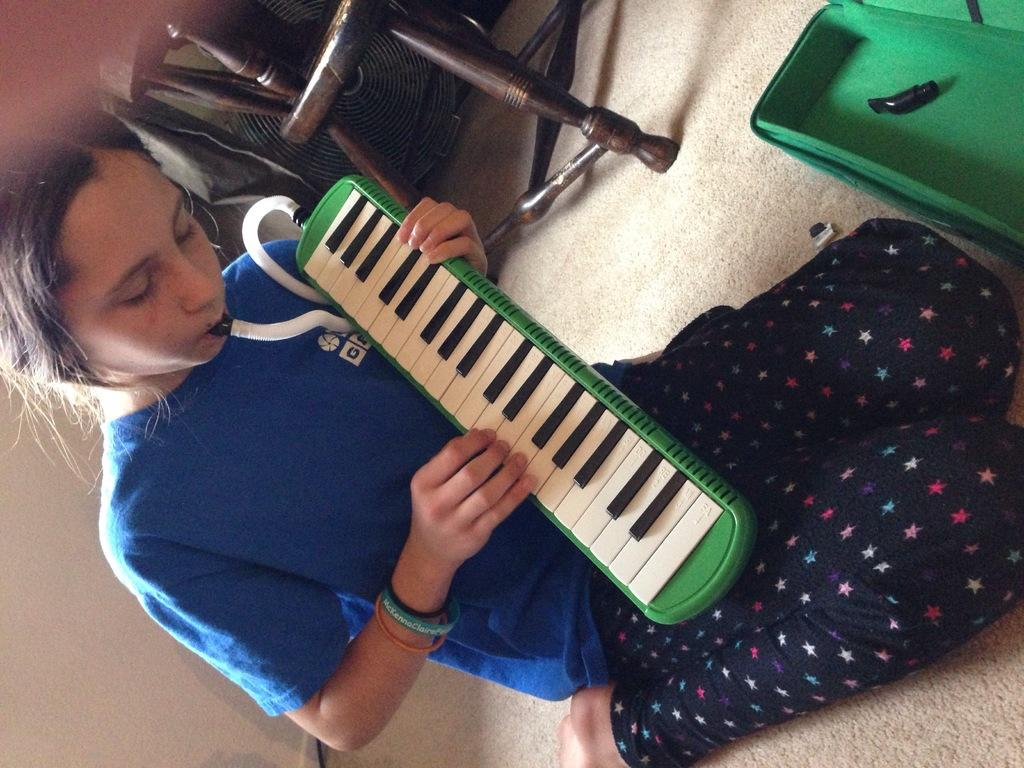Who is the main subject in the image? There is a woman in the image. What is the woman doing in the image? The woman is sitting on the floor and playing a musical instrument. What is in front of the woman? There is a box in front of the woman. What can be seen in the background of the image? There is a chair and other objects visible in the background of the image. What type of faucet can be seen in the image? There is no faucet present in the image. Is the woman drinking eggnog while playing the musical instrument? There is no mention of eggnog in the image, and the woman is not shown drinking anything. 